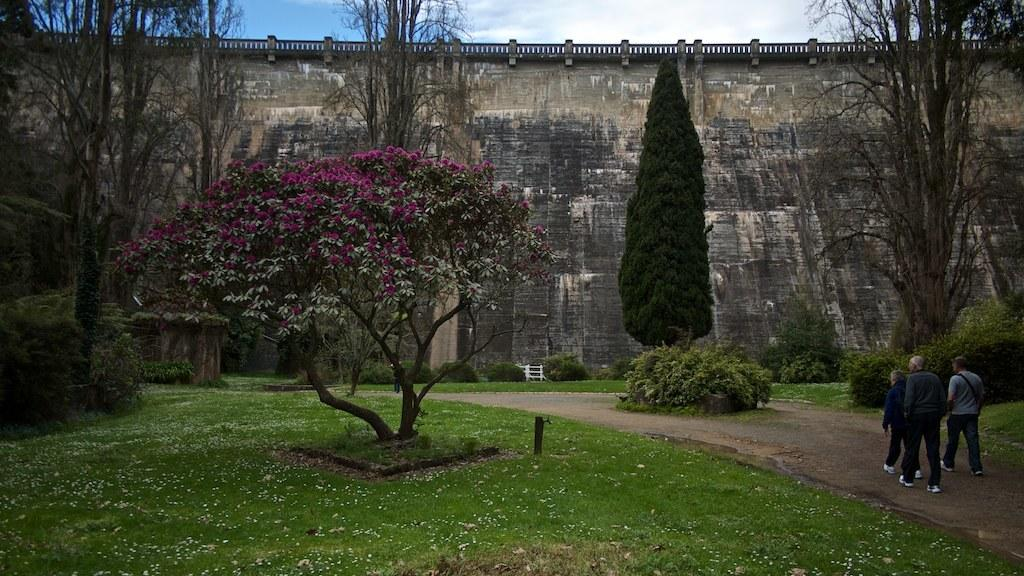How many people are in the image? There are three people in the image. What are the people doing in the image? The people are walking on the ground in the image. What type of vegetation can be seen in the image? There are trees and grass visible in the image. What structures can be seen in the image? There is a wall and a fence in the image. What else is present in the image besides the people and structures? There are some objects in the image. What can be seen in the background of the image? The sky is visible in the background of the image. What type of whip is being used by the crook in the image? There is no crook or whip present in the image. What type of exchange is taking place between the people in the image? The image does not show any exchange between the people; they are simply walking on the ground. 